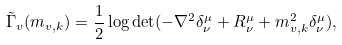<formula> <loc_0><loc_0><loc_500><loc_500>\tilde { \Gamma } _ { v } ( m _ { v , k } ) = \frac { 1 } { 2 } \log \det ( - \nabla ^ { 2 } \delta ^ { \mu } _ { \nu } + R ^ { \mu } _ { \nu } + m _ { v , k } ^ { 2 } \delta ^ { \mu } _ { \nu } ) ,</formula> 